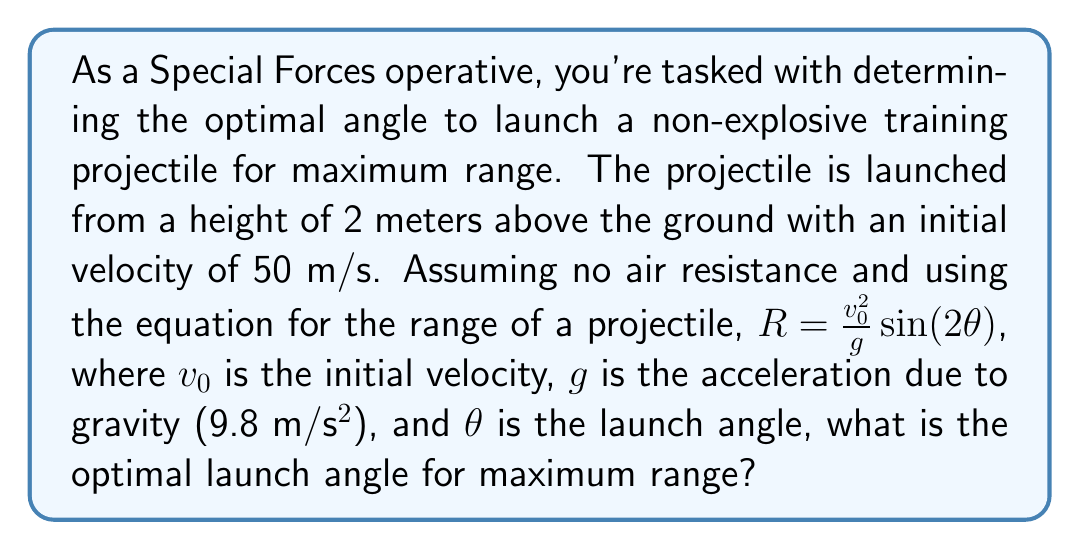Give your solution to this math problem. To solve this problem, we need to understand that the maximum range occurs when $\sin(2\theta)$ is at its maximum value. Let's break this down step-by-step:

1) The range equation given is:
   $R = \frac{v_0^2}{g} \sin(2\theta)$

2) We know that $\sin(x)$ reaches its maximum value of 1 when $x = 90°$ or $\frac{\pi}{2}$ radians.

3) Therefore, $\sin(2\theta)$ will be maximum when:
   $2\theta = 90°$ or $\frac{\pi}{2}$ radians

4) Solving for $\theta$:
   $\theta = 45°$ or $\frac{\pi}{4}$ radians

5) We can verify this mathematically by taking the derivative of the range equation with respect to $\theta$, setting it to zero, and solving for $\theta$:

   $\frac{dR}{d\theta} = \frac{v_0^2}{g} \cdot 2\cos(2\theta) = 0$
   
   $2\cos(2\theta) = 0$
   
   $\cos(2\theta) = 0$
   
   $2\theta = 90°$ or $\frac{\pi}{2}$ radians
   
   $\theta = 45°$ or $\frac{\pi}{4}$ radians

6) Note that the initial height of 2 meters doesn't affect the optimal angle in this idealized scenario, but it would increase the actual range slightly.

Therefore, the optimal launch angle for maximum range is 45°.
Answer: The optimal launch angle for maximum range is 45°. 